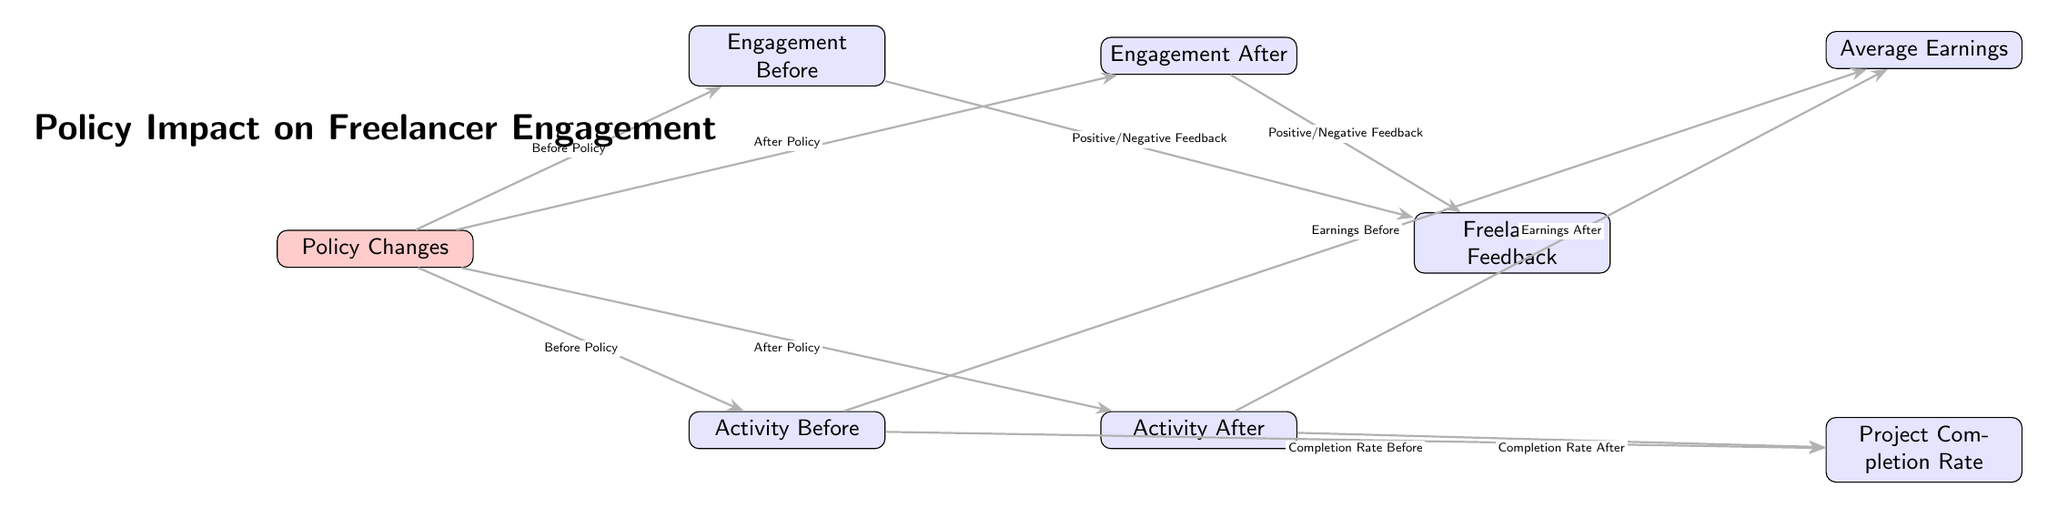What is the central theme of the diagram? The diagram centers around the impact of policy changes on freelancer engagement, illustrating how various metrics changed before and after these changes.
Answer: Policy Impact on Freelancer Engagement How many nodes are there in total? The diagram contains six nodes: Policy Changes, Engagement Before, Engagement After, Activity Before, Activity After, and Freelancer Feedback (which connects completion rate and average earnings) indicating relevant metrics in response to policy changes.
Answer: Six What is one of the metrics assessed after policy changes? The diagram shows that after policy changes, engagement levels and activity levels are particularly assessed through metrics like Engagement After and Activity After.
Answer: Engagement After What type of feedback is represented in the diagram? The diagram conveys that freelancer feedback can be positive or negative, reflecting the responses before and after the policy changes.
Answer: Positive/Negative Feedback How did freelancer engagement evolve as a result of the policy changes? The diagram illustrates a direct correlation between the policy changes and subsequent shifts in engagement metrics, indicating an overall evolution from Engagement Before to Engagement After.
Answer: Increased/Decreased Engagement What influences project completion rates according to the diagram? Based on the structure, engagement and activity levels before or after the policy changes influence the Project Completion Rate, demonstrating a relationship impacted by freelancer activity.
Answer: Activity Before/Activity After What two aspects directly relate to earnings in the diagram? The diagram specifies that Earnings Before and Earnings After are influenced by activity levels, showing the direct relationship between project-related actions and financial outcomes.
Answer: Earnings Before and Earnings After Which aspect flows directly from engagement before the policy changes? The flow demonstrates that Positive/Negative Feedback derives directly from Engagement Before, showing how freelancer sentiments shape perceptions prior to policy alterations.
Answer: Positive/Negative Feedback 